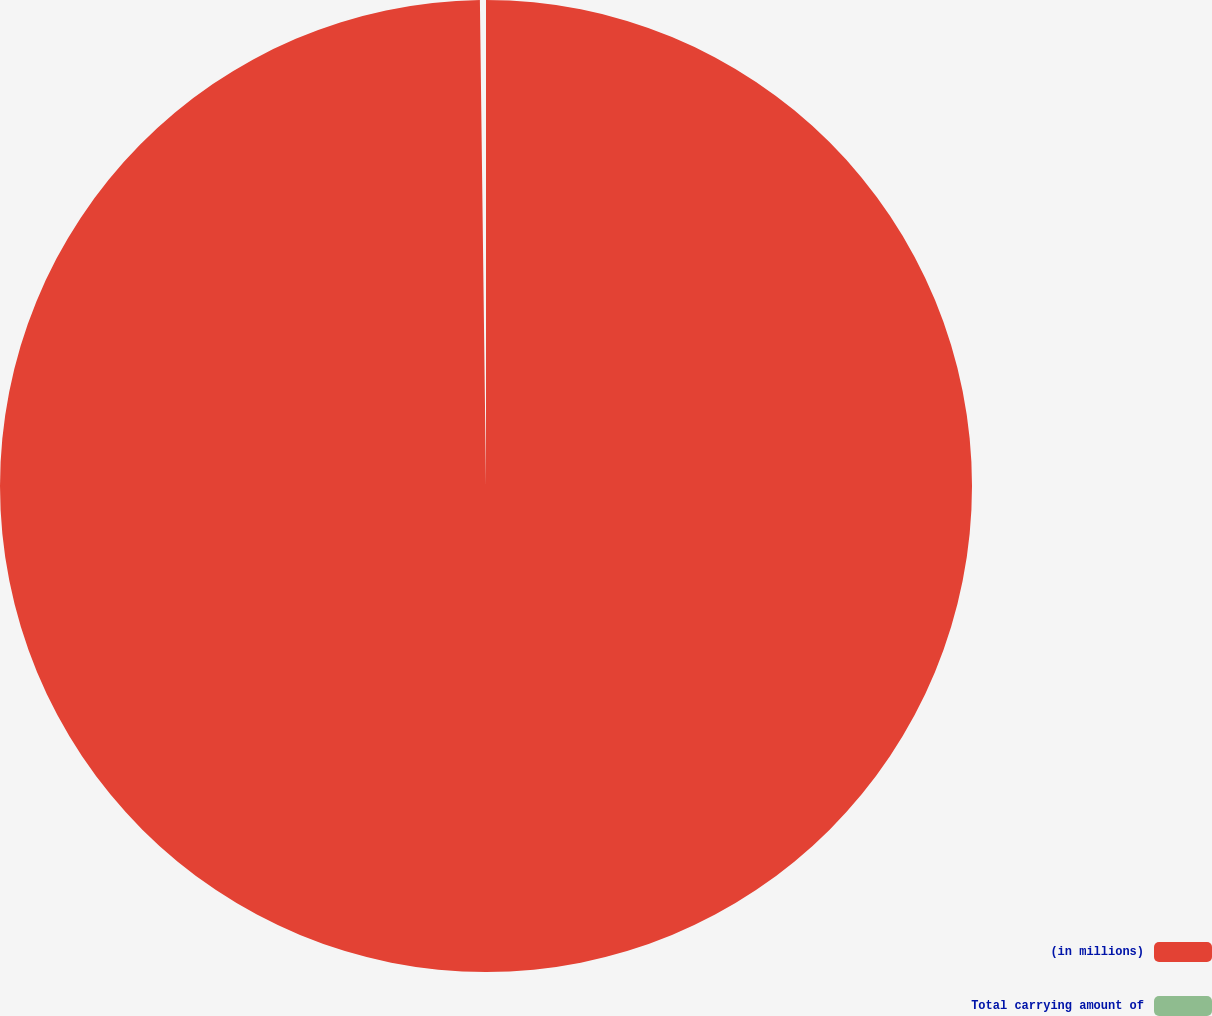Convert chart to OTSL. <chart><loc_0><loc_0><loc_500><loc_500><pie_chart><fcel>(in millions)<fcel>Total carrying amount of<nl><fcel>99.8%<fcel>0.2%<nl></chart> 